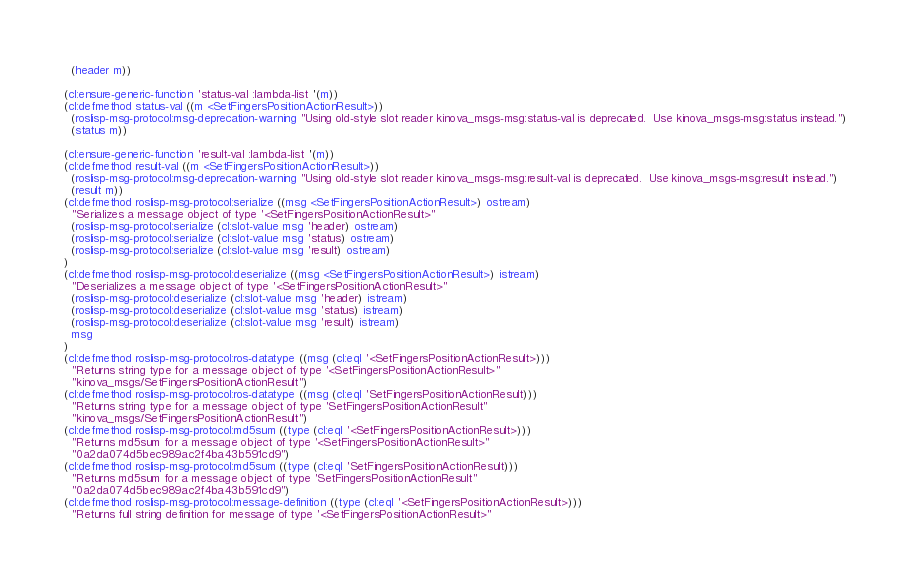Convert code to text. <code><loc_0><loc_0><loc_500><loc_500><_Lisp_>  (header m))

(cl:ensure-generic-function 'status-val :lambda-list '(m))
(cl:defmethod status-val ((m <SetFingersPositionActionResult>))
  (roslisp-msg-protocol:msg-deprecation-warning "Using old-style slot reader kinova_msgs-msg:status-val is deprecated.  Use kinova_msgs-msg:status instead.")
  (status m))

(cl:ensure-generic-function 'result-val :lambda-list '(m))
(cl:defmethod result-val ((m <SetFingersPositionActionResult>))
  (roslisp-msg-protocol:msg-deprecation-warning "Using old-style slot reader kinova_msgs-msg:result-val is deprecated.  Use kinova_msgs-msg:result instead.")
  (result m))
(cl:defmethod roslisp-msg-protocol:serialize ((msg <SetFingersPositionActionResult>) ostream)
  "Serializes a message object of type '<SetFingersPositionActionResult>"
  (roslisp-msg-protocol:serialize (cl:slot-value msg 'header) ostream)
  (roslisp-msg-protocol:serialize (cl:slot-value msg 'status) ostream)
  (roslisp-msg-protocol:serialize (cl:slot-value msg 'result) ostream)
)
(cl:defmethod roslisp-msg-protocol:deserialize ((msg <SetFingersPositionActionResult>) istream)
  "Deserializes a message object of type '<SetFingersPositionActionResult>"
  (roslisp-msg-protocol:deserialize (cl:slot-value msg 'header) istream)
  (roslisp-msg-protocol:deserialize (cl:slot-value msg 'status) istream)
  (roslisp-msg-protocol:deserialize (cl:slot-value msg 'result) istream)
  msg
)
(cl:defmethod roslisp-msg-protocol:ros-datatype ((msg (cl:eql '<SetFingersPositionActionResult>)))
  "Returns string type for a message object of type '<SetFingersPositionActionResult>"
  "kinova_msgs/SetFingersPositionActionResult")
(cl:defmethod roslisp-msg-protocol:ros-datatype ((msg (cl:eql 'SetFingersPositionActionResult)))
  "Returns string type for a message object of type 'SetFingersPositionActionResult"
  "kinova_msgs/SetFingersPositionActionResult")
(cl:defmethod roslisp-msg-protocol:md5sum ((type (cl:eql '<SetFingersPositionActionResult>)))
  "Returns md5sum for a message object of type '<SetFingersPositionActionResult>"
  "0a2da074d5bec989ac2f4ba43b591cd9")
(cl:defmethod roslisp-msg-protocol:md5sum ((type (cl:eql 'SetFingersPositionActionResult)))
  "Returns md5sum for a message object of type 'SetFingersPositionActionResult"
  "0a2da074d5bec989ac2f4ba43b591cd9")
(cl:defmethod roslisp-msg-protocol:message-definition ((type (cl:eql '<SetFingersPositionActionResult>)))
  "Returns full string definition for message of type '<SetFingersPositionActionResult>"</code> 